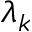<formula> <loc_0><loc_0><loc_500><loc_500>\lambda _ { k }</formula> 